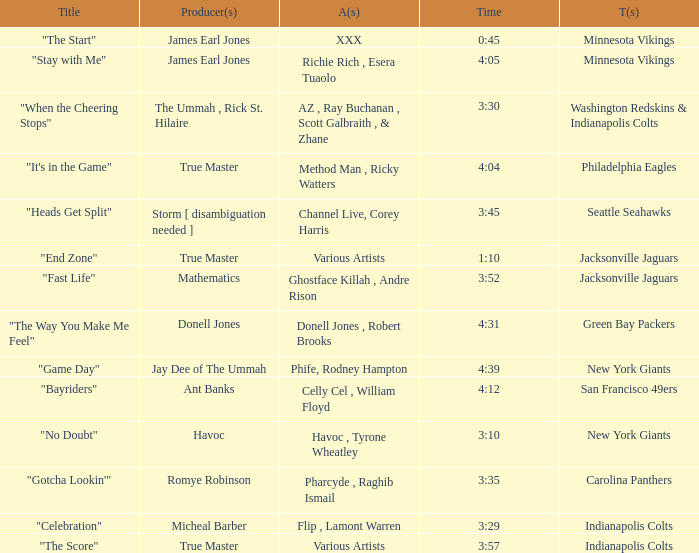How long is the XXX track used by the Minnesota Vikings? 0:45. 